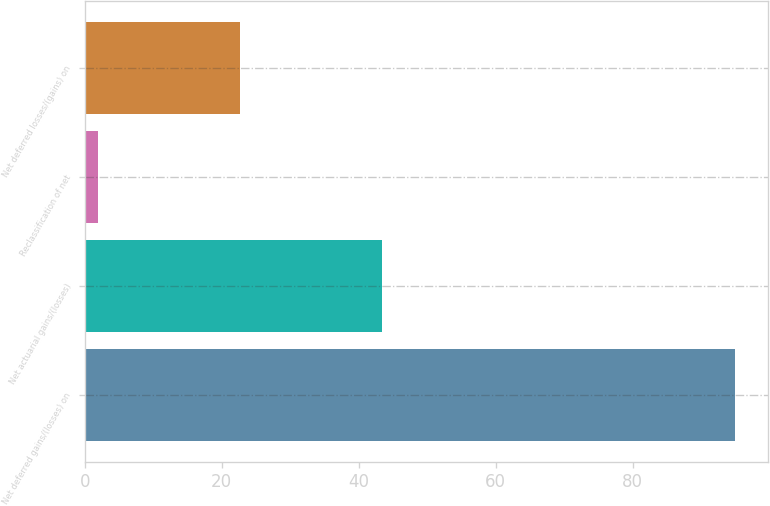Convert chart to OTSL. <chart><loc_0><loc_0><loc_500><loc_500><bar_chart><fcel>Net deferred gains/(losses) on<fcel>Net actuarial gains/(losses)<fcel>Reclassification of net<fcel>Net deferred losses/(gains) on<nl><fcel>95<fcel>43.4<fcel>2<fcel>22.7<nl></chart> 